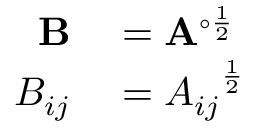<formula> <loc_0><loc_0><loc_500><loc_500>\begin{array} { r l } { B } & = A ^ { \circ { \frac { 1 } { 2 } } } } \\ { B _ { i j } } & = { A _ { i j } } ^ { \frac { 1 } { 2 } } } \end{array}</formula> 